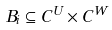Convert formula to latex. <formula><loc_0><loc_0><loc_500><loc_500>B _ { i } \subseteq C ^ { U } \times C ^ { W }</formula> 